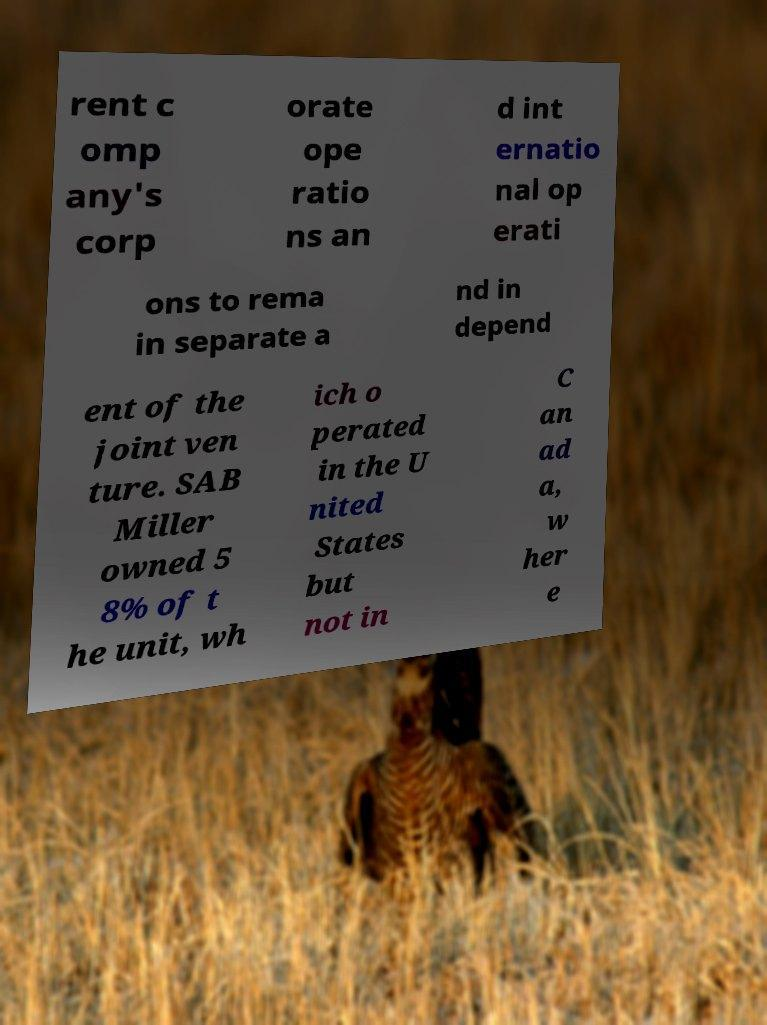What messages or text are displayed in this image? I need them in a readable, typed format. rent c omp any's corp orate ope ratio ns an d int ernatio nal op erati ons to rema in separate a nd in depend ent of the joint ven ture. SAB Miller owned 5 8% of t he unit, wh ich o perated in the U nited States but not in C an ad a, w her e 